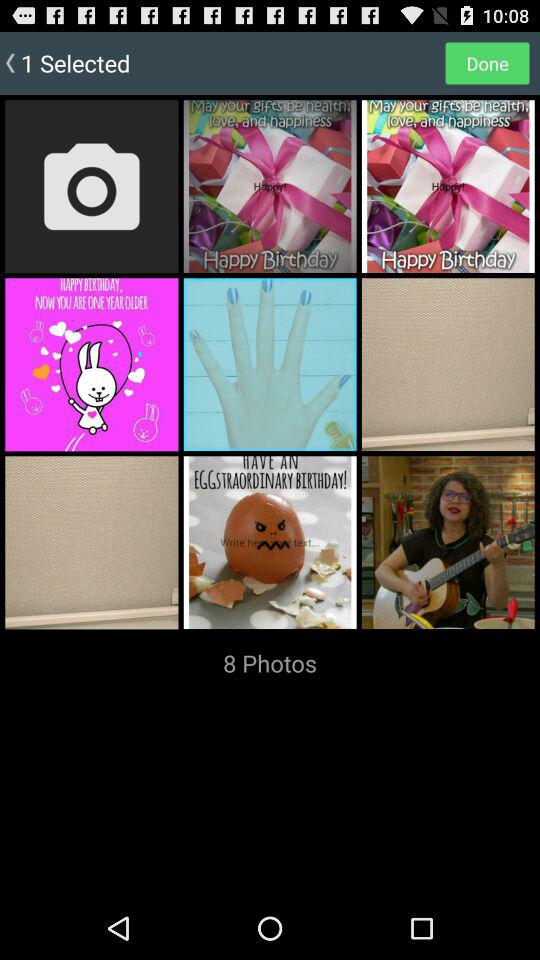How many photos are in the album?
Answer the question using a single word or phrase. 8 